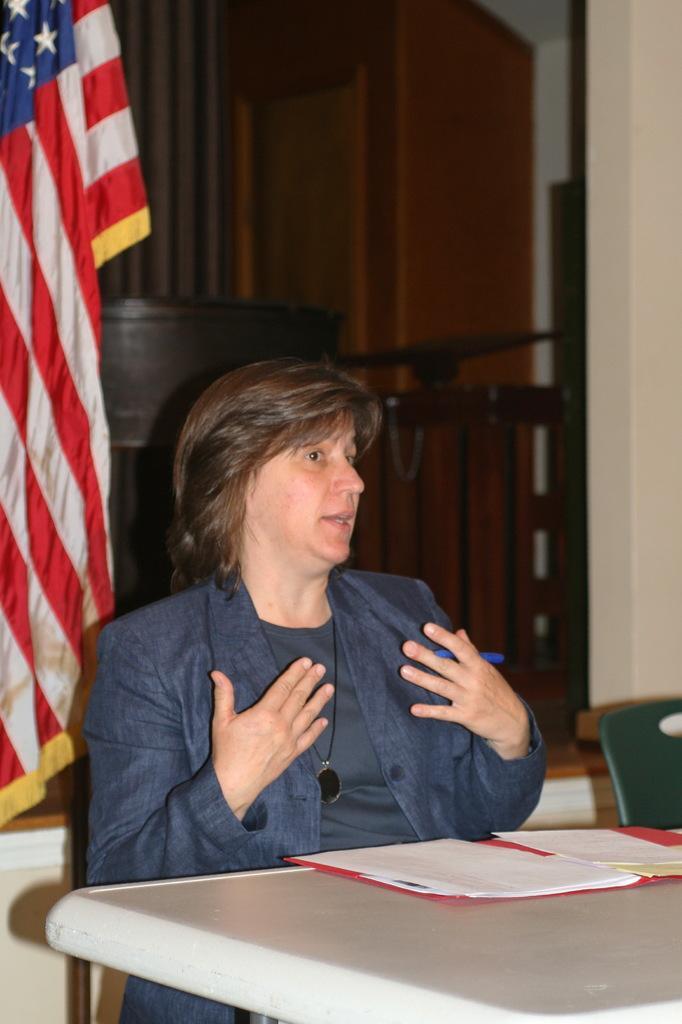Please provide a concise description of this image. In this image i can see a woman sitting in front of a table. On the table i can see few papers. In the background i can see a flag. 